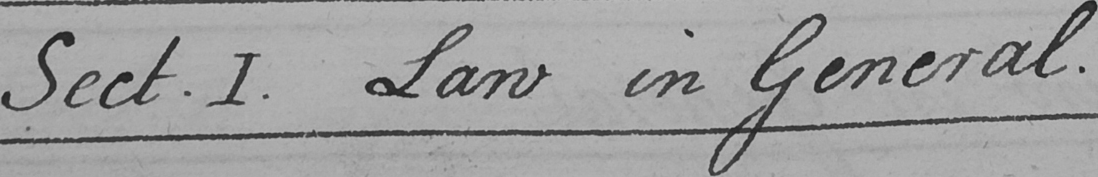Can you read and transcribe this handwriting? Sect . I . Law in General . 